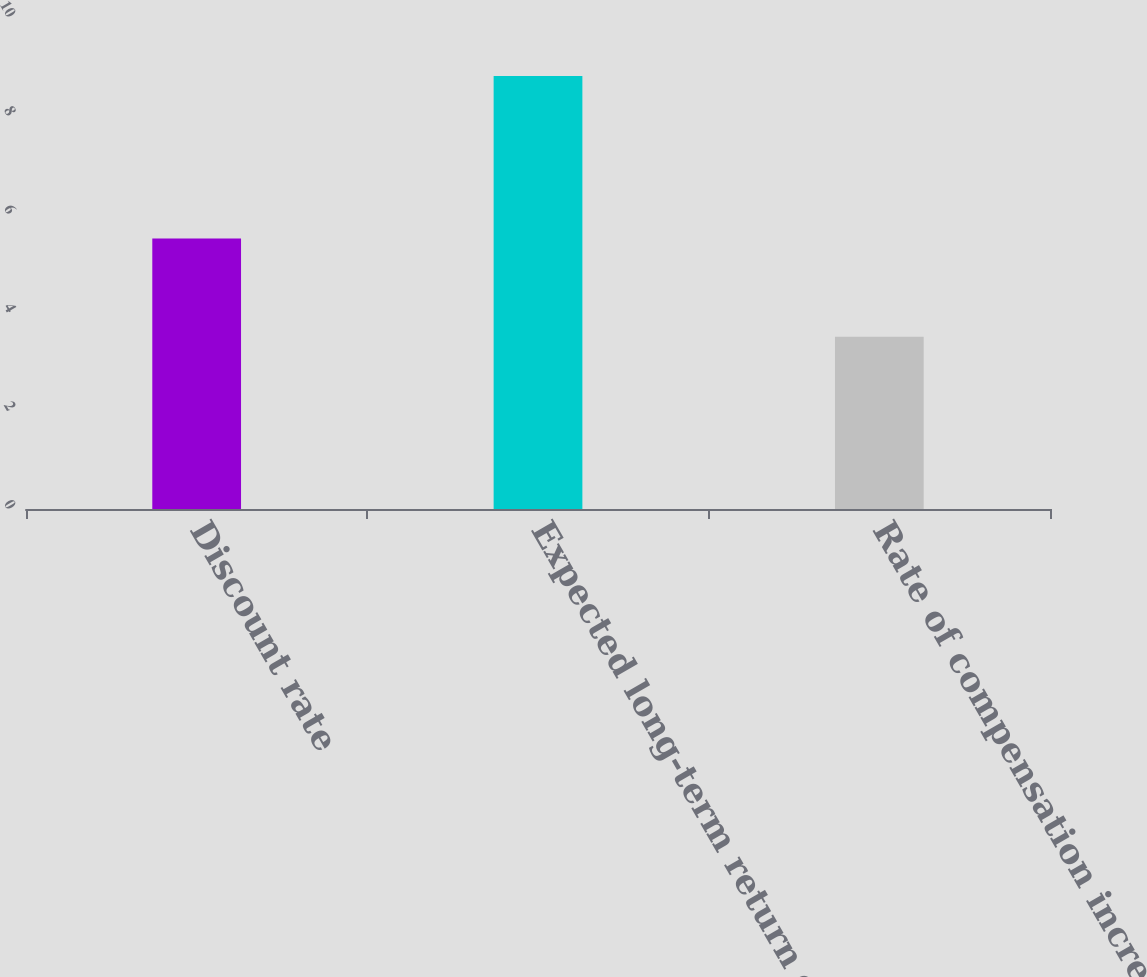<chart> <loc_0><loc_0><loc_500><loc_500><bar_chart><fcel>Discount rate<fcel>Expected long-term return on<fcel>Rate of compensation increase<nl><fcel>5.5<fcel>8.8<fcel>3.5<nl></chart> 